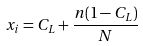<formula> <loc_0><loc_0><loc_500><loc_500>x _ { i } = C _ { L } + \frac { n ( 1 - C _ { L } ) } { N }</formula> 